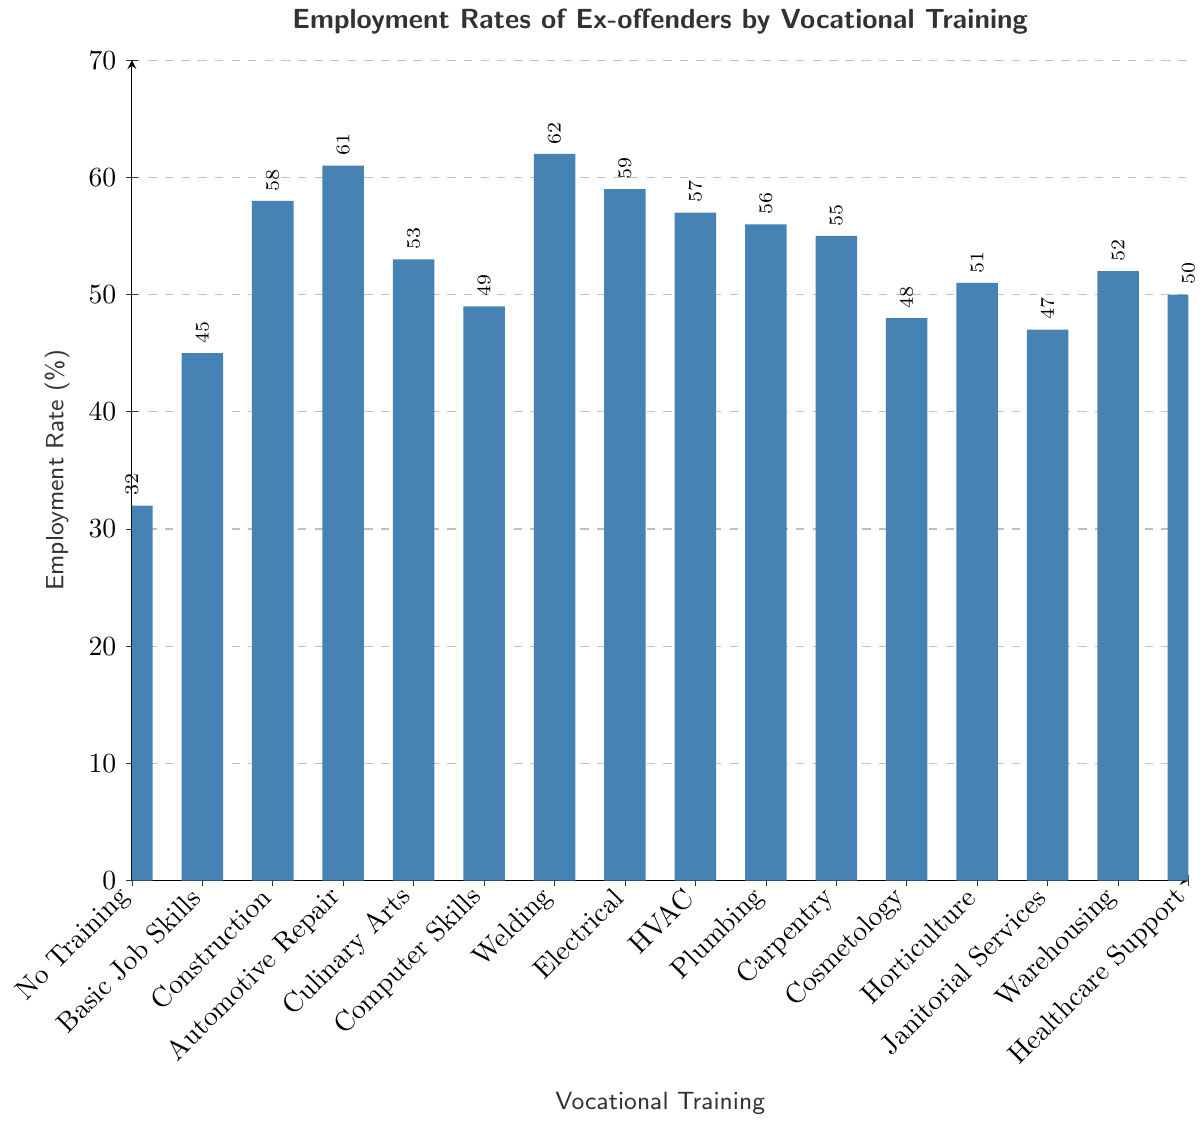What's the average employment rate of all groups combined? To find the average employment rate, sum all the employment rates and divide by the total number of groups. The sum of employment rates is (32 + 45 + 58 + 61 + 53 + 49 + 62 + 59 + 57 + 56 + 55 + 48 + 51 + 47 + 52 + 50) = 835. There are 16 groups, so the average is 835/16 = 52.1875.
Answer: 52.1875 Which vocational training resulted in the highest employment rate on the chart? Identify the bar with the highest value. Welding has the highest employment rate at 62%.
Answer: Welding Compare the employment rates of HVAC and Plumbing. Which one is higher? Look at the heights of the bars for HVAC and Plumbing. HVAC has an employment rate of 57%, while Plumbing has an employment rate of 56%.
Answer: HVAC What's the range of the employment rates across all vocational training categories? To find the range, subtract the smallest employment rate from the largest employment rate. The smallest rate is 32% (No Training), and the largest rate is 62% (Welding). The range is 62 - 32 = 30%.
Answer: 30% How many vocational training categories have an employment rate greater than 50%? Count the bars where the employment rate is greater than 50%. These categories are Construction, Automotive Repair, Culinary Arts, Welding, Electrical, HVAC, Plumbing, Carpentry, Horticulture, and Warehousing.
Answer: 10 Identify the vocational training category with the lowest employment rate. Identify the bar with the lowest value. No Training has the lowest employment rate at 32%.
Answer: No Training What's the difference in employment rates between Automotive Repair and Computer Skills? Subtract the employment rate of Computer Skills from that of Automotive Repair. Automotive Repair has an employment rate of 61%, and Computer Skills has an employment rate of 49%. The difference is 61 - 49 = 12%.
Answer: 12% Which two vocational training categories have the closest employment rates, and what is the difference between them? Compare the employment rates of each category to find the pair with the smallest difference. HVAC and Plumbing have rates of 57% and 56% respectively, with a difference of 1%.
Answer: HVAC and Plumbing, 1% What is the median employment rate for these vocational training categories? To find the median, first arrange all the employment rates in numerical order: [32, 45, 47, 48, 49, 50, 51, 52, 53, 55, 56, 57, 58, 59, 61, 62]. For 16 numbers, the median is the average of the 8th and 9th values: (52 + 53) / 2 = 52.5.
Answer: 52.5 